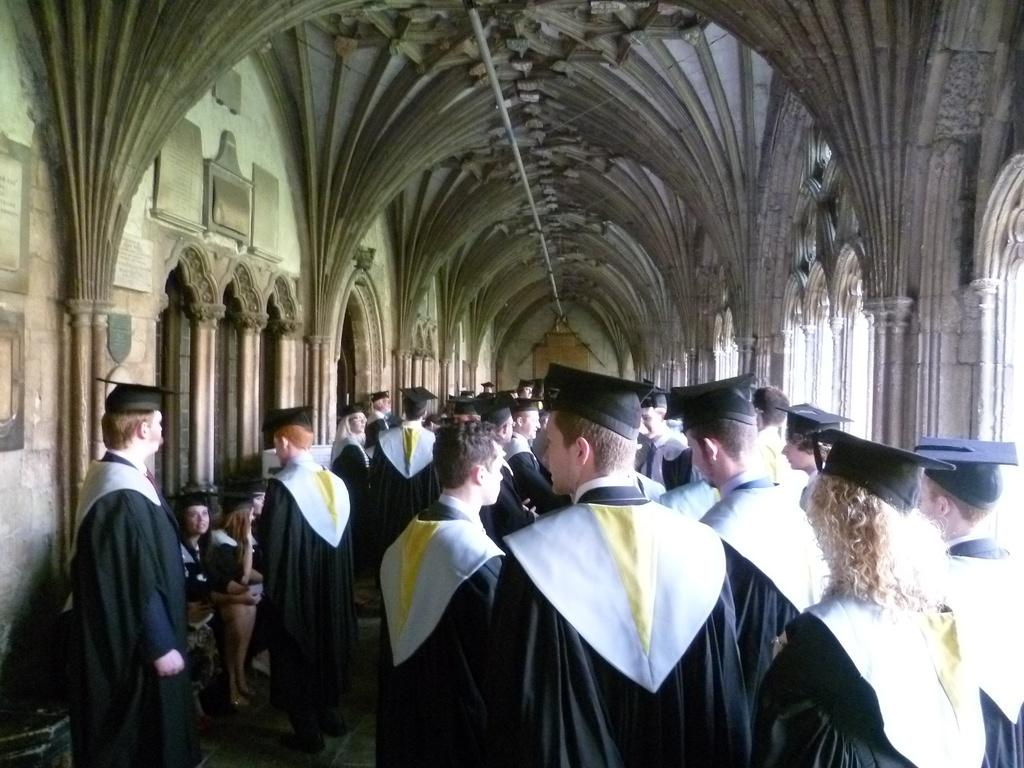What are the people in the image doing? Some people are standing, while others are sitting in the image. Where are the people located? The people are inside a building. What grade is the person in the image receiving? There is no indication of a person receiving a grade in the image. What type of education is being taught in the image? There is no indication of any educational activity taking place in the image. 